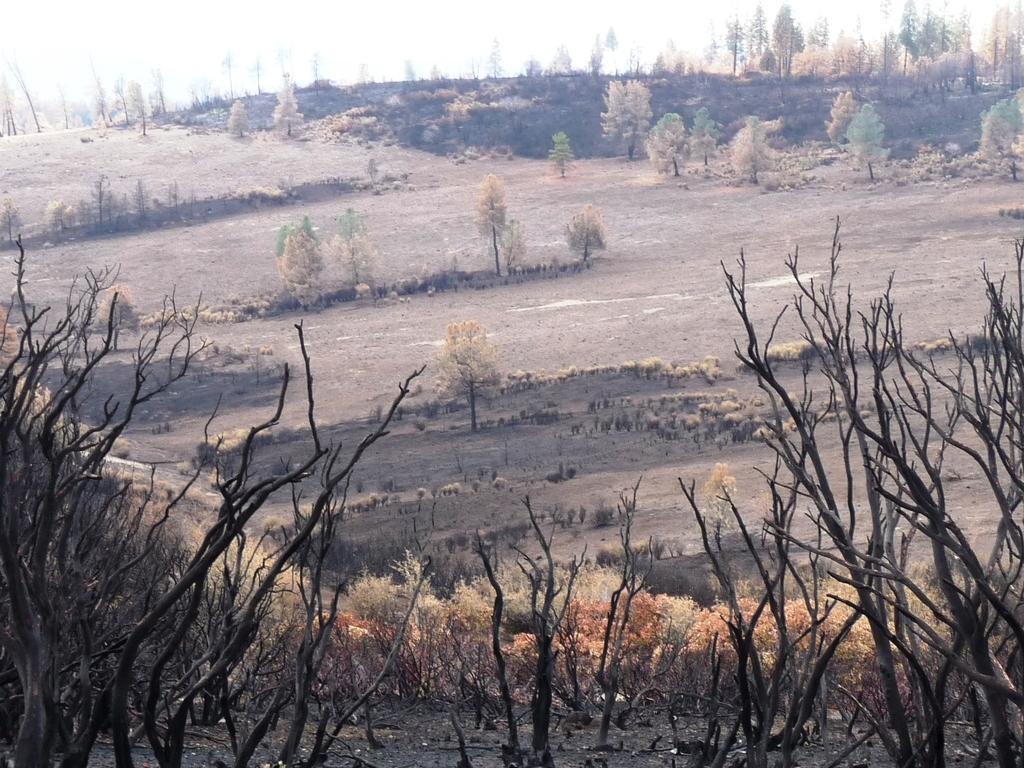Can you describe this image briefly? In this image I can see few brown and green color trees and few dry trees. The sky is in white color. 